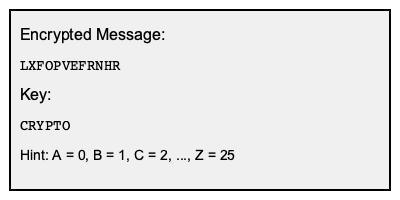Decipher the given message encoded with a Vigenère cipher using the provided key. What is the decrypted message? To decipher the Vigenère cipher, follow these steps:

1. Convert the key and ciphertext to numbers (A=0, B=1, ..., Z=25):
   Key: CRYPTO = 2 17 24 15 19 14
   Ciphertext: LXFOPVEFRNHR = 11 23 5 14 15 21 4 5 17 13 7 17

2. Repeat the key to match the length of the ciphertext:
   CRYPTOC RYPTOCR YPTO

3. Subtract the key from the ciphertext (mod 26):
   11 23 5 14 15 21 4 5 17 13 7 17 (ciphertext)
   - 2 17 24 15 19 14 2 17 24 15 19 14 (key)
   --------------------------------
   9 6 7 25 22 7 2 14 19 24 14 3 (mod 26)

4. Convert the numbers back to letters:
   9 6 7 25 22 7 2 14 19 24 14 3
   J G H Z W H C O T Y O D

Therefore, the decrypted message is JGHZWHCOTYPD.
Answer: JGHZWHCOTYPD 